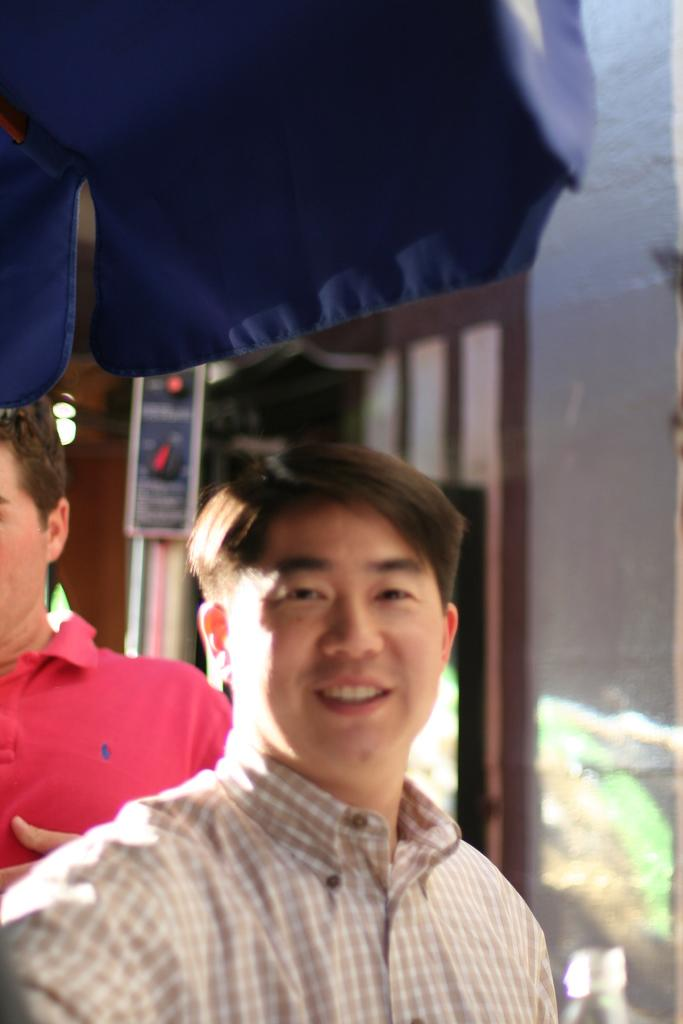How many people are in the image? There are two persons in the image. Can you describe the background of the image? The background appears blurry, and there is a wall visible. What object is partially visible at the top of the image? Part of an umbrella is visible at the top of the image. What type of bread can be seen hanging from the wall in the image? There is no bread present in the image, and nothing is hanging from the wall. 